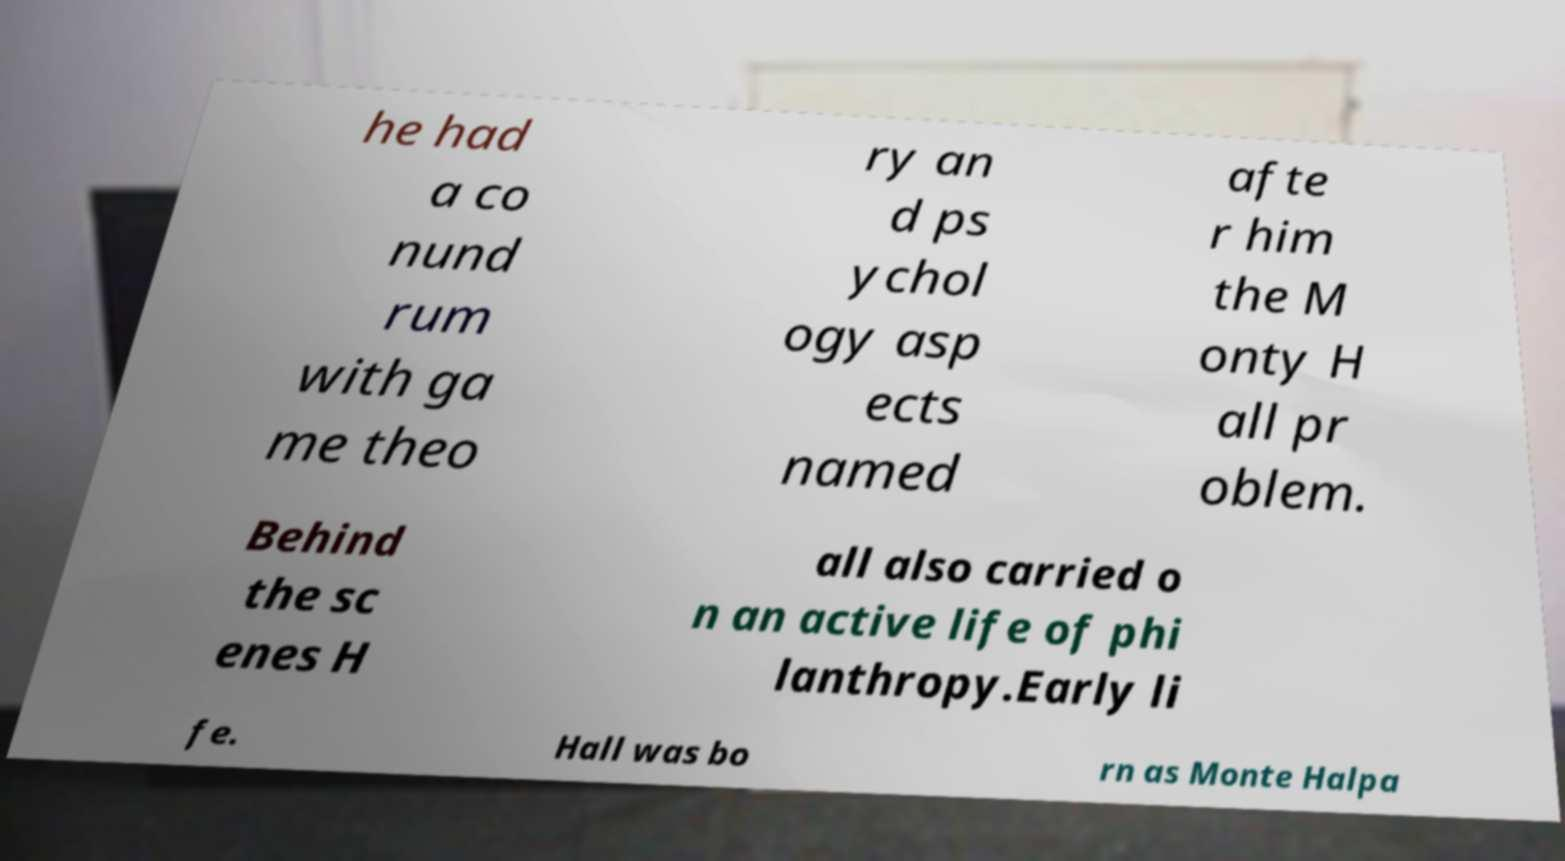Could you extract and type out the text from this image? he had a co nund rum with ga me theo ry an d ps ychol ogy asp ects named afte r him the M onty H all pr oblem. Behind the sc enes H all also carried o n an active life of phi lanthropy.Early li fe. Hall was bo rn as Monte Halpa 